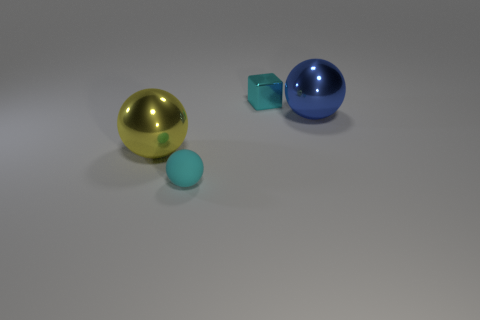Are there an equal number of big blue metallic things that are to the left of the large yellow ball and tiny brown balls?
Provide a short and direct response. Yes. What material is the tiny object that is in front of the tiny thing that is behind the shiny ball that is on the right side of the small cyan cube?
Offer a very short reply. Rubber. What is the shape of the other tiny thing that is the same material as the yellow object?
Your answer should be very brief. Cube. Is there anything else that has the same color as the block?
Your answer should be compact. Yes. How many big metal objects are right of the cyan object that is behind the big thing that is on the left side of the cyan metal cube?
Provide a succinct answer. 1. What number of cyan things are either large objects or spheres?
Make the answer very short. 1. There is a cyan metallic block; does it have the same size as the cyan thing in front of the small cyan block?
Make the answer very short. Yes. What is the material of the cyan object that is the same shape as the big yellow shiny thing?
Your answer should be very brief. Rubber. What number of other objects are there of the same size as the yellow thing?
Make the answer very short. 1. The small cyan thing behind the shiny object that is to the left of the thing that is behind the blue thing is what shape?
Keep it short and to the point. Cube. 